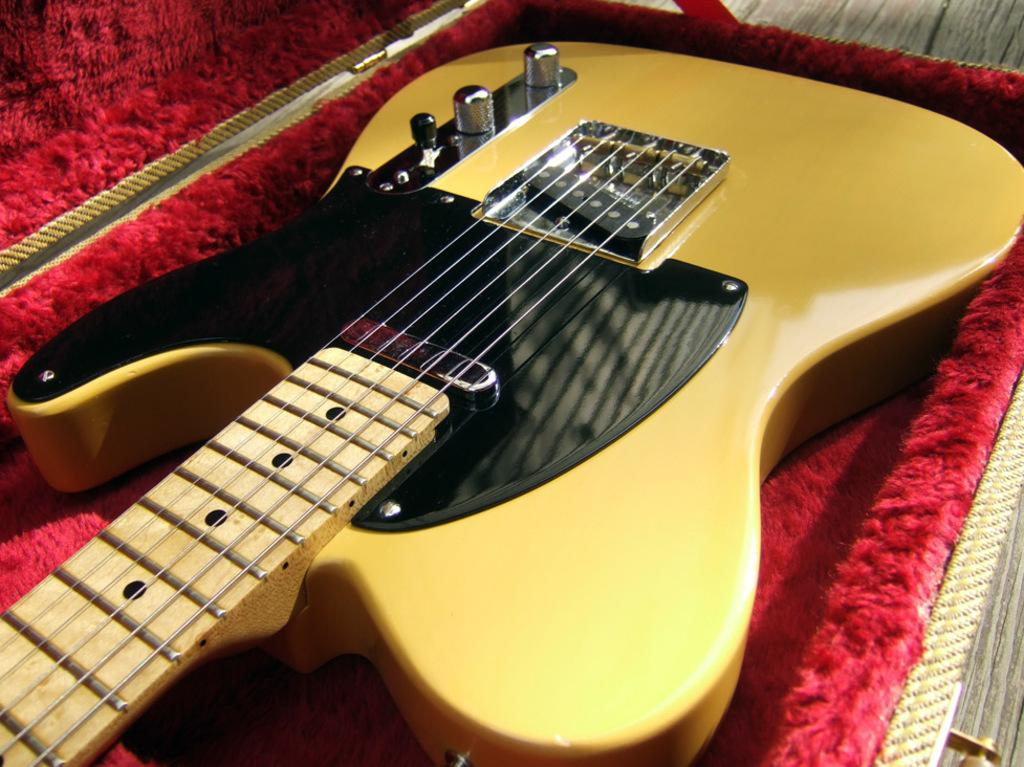What type of musical instrument is in the image? There is a golden color guitar in the image. How is the guitar being stored or transported? The guitar is kept in a red color box. What type of bread is visible in the image? There is no bread or loaf present in the image; it features a golden color guitar in a red color box. 